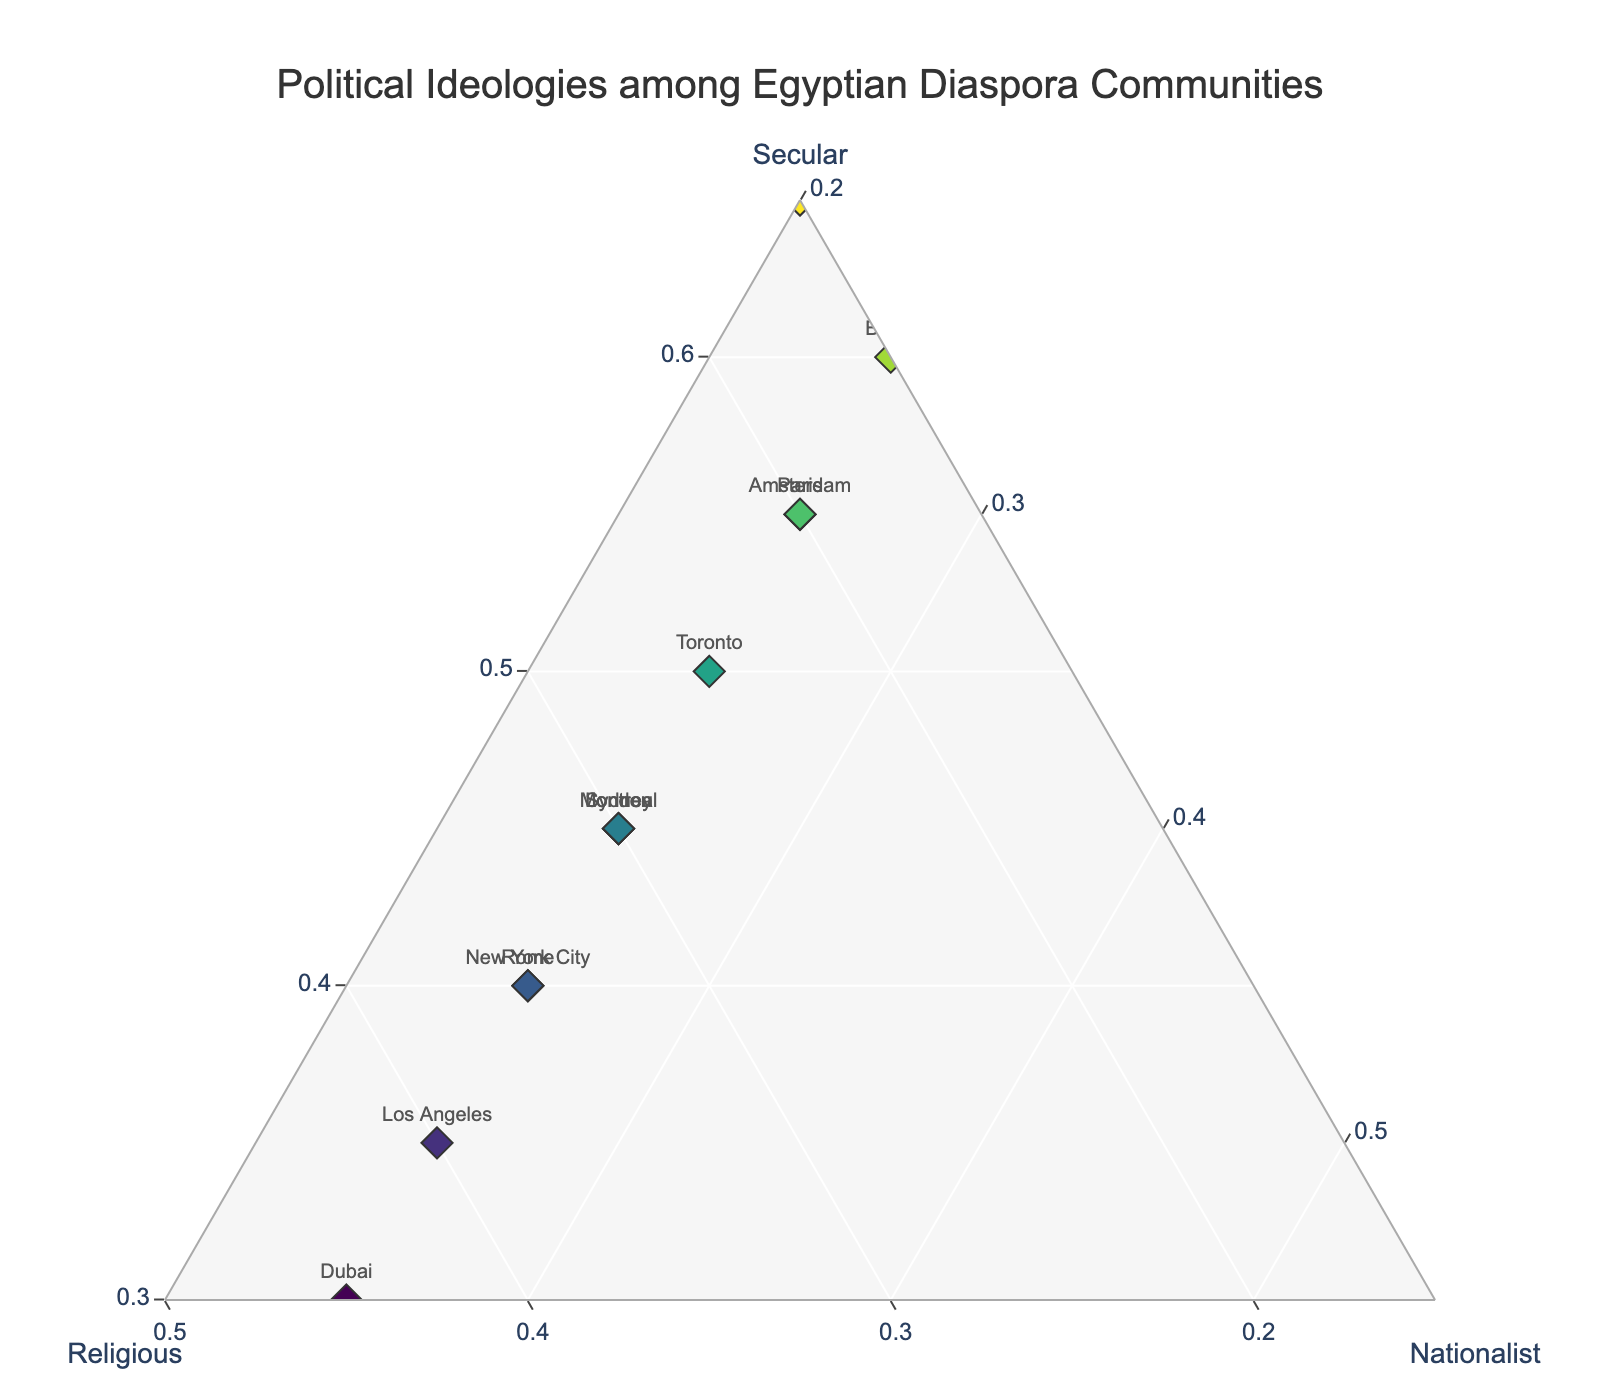What is the title of the figure? The title is displayed at the top of the figure and describes the overall subject of the plot.
Answer: Political Ideologies among Egyptian Diaspora Communities Which community has the highest percentage of secular ideology? To determine this, look for the data point with the highest value on the 'Secular' axis.
Answer: Stockholm Which communities have a greater percentage of religious ideology than secular ideology? Compare the values of 'Religious' and 'Secular' for each community. Identify which ones have a higher value in the 'Religious' column.
Answer: Los Angeles, Dubai What is the range of values for the nationalist ideology among the communities? Identify the minimum and maximum values in the 'Nationalist' column in the plot.
Answer: 20 to 25 How many communities have the same percentages for nationalist ideologies? Look for clusters of data points with the same 'Nationalist' values.
Answer: 10 Which community has the most balanced distribution of the three ideologies? A balanced distribution means the percentages of secular, religious, and nationalist ideologies are close to each other.
Answer: New York City Is there any community with less than 20% in religious ideology? Check if any data points fall below the 20% mark on the 'Religious' axis.
Answer: Paris, Berlin, Stockholm Between London and Toronto, which community has a higher percentage of secular ideology? Compare the values on the 'Secular' axis for London and Toronto.
Answer: Toronto How many communities exhibit secular ideology percentages over 50%? Identify the data points that exceed the 50% mark on the 'Secular' axis.
Answer: 4 What is the average percentage of nationalist ideology across all communities? Calculate the mean of the 'Nationalist' percentages from all data points. Explanation: (25+25+25+25+25+25+25+25+25+25+25+20)/12 = 25.
Answer: 25 